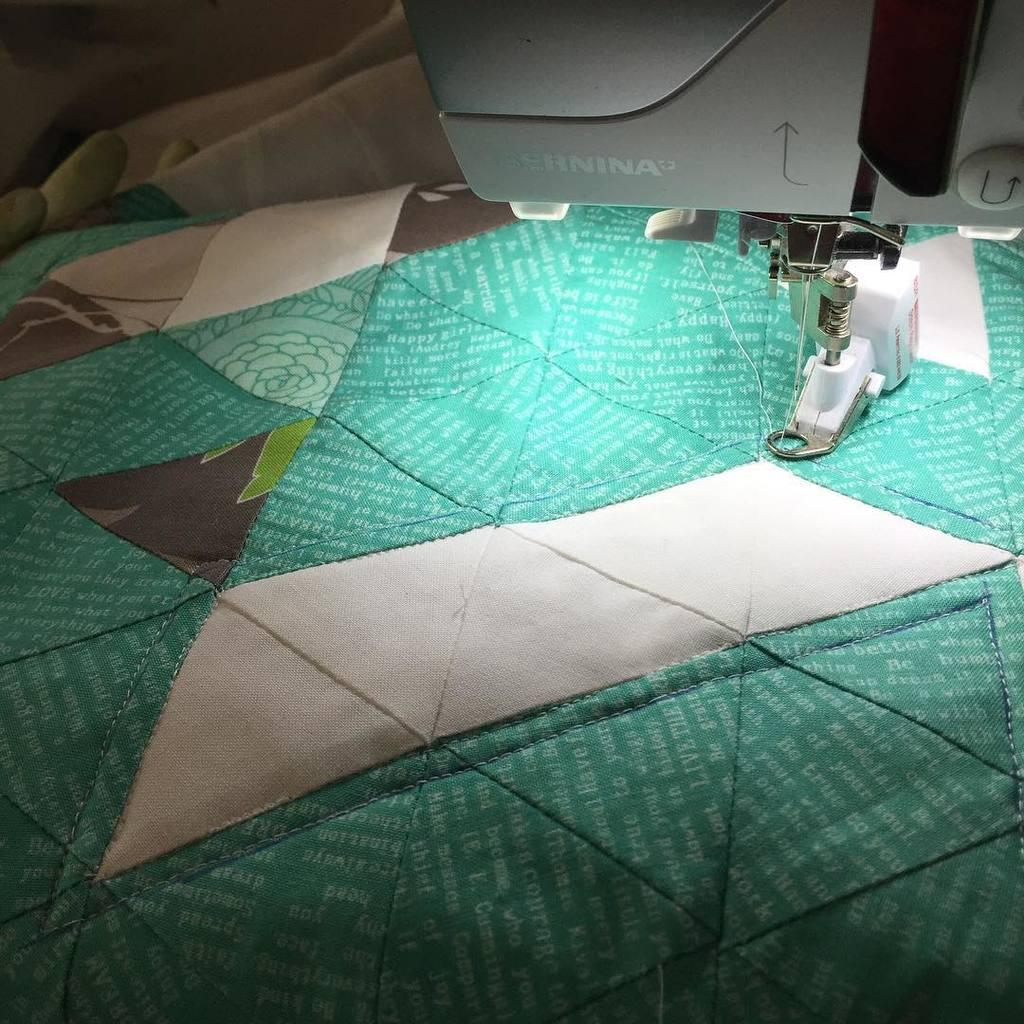What is the main object in the image? There is a sewing machine in the image. What else can be seen in the image? There is a cloth in the image. What might the sewing machine be used for? The sewing machine might be used for sewing or stitching the cloth. How many trucks are parked near the sewing machine in the image? There are no trucks present in the image; it only features a sewing machine and a cloth. What type of frogs can be seen hopping on the sewing machine in the image? There are no frogs present in the image; it only features a sewing machine and a cloth. 